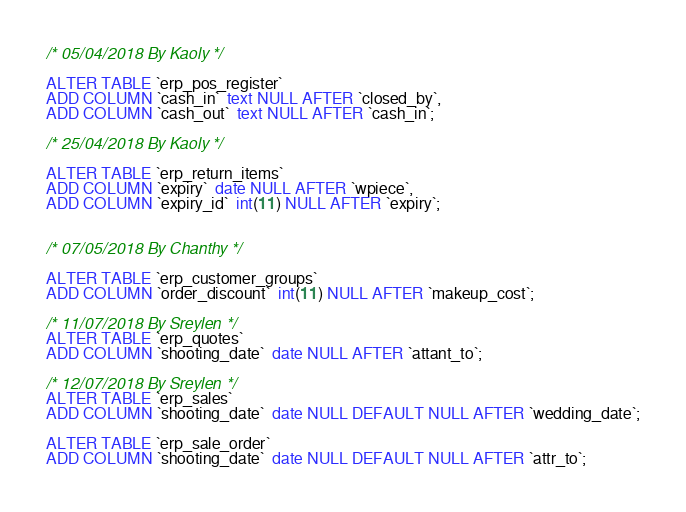Convert code to text. <code><loc_0><loc_0><loc_500><loc_500><_SQL_>/* 05/04/2018 By Kaoly */

ALTER TABLE `erp_pos_register`
ADD COLUMN `cash_in`  text NULL AFTER `closed_by`,
ADD COLUMN `cash_out`  text NULL AFTER `cash_in`;

/* 25/04/2018 By Kaoly */

ALTER TABLE `erp_return_items`
ADD COLUMN `expiry`  date NULL AFTER `wpiece`,
ADD COLUMN `expiry_id`  int(11) NULL AFTER `expiry`;


/* 07/05/2018 By Chanthy */

ALTER TABLE `erp_customer_groups`
ADD COLUMN `order_discount`  int(11) NULL AFTER `makeup_cost`;

/* 11/07/2018 By Sreylen */
ALTER TABLE `erp_quotes`
ADD COLUMN `shooting_date`  date NULL AFTER `attant_to`;

/* 12/07/2018 By Sreylen */
ALTER TABLE `erp_sales`
ADD COLUMN `shooting_date`  date NULL DEFAULT NULL AFTER `wedding_date`;

ALTER TABLE `erp_sale_order`
ADD COLUMN `shooting_date`  date NULL DEFAULT NULL AFTER `attr_to`;
</code> 